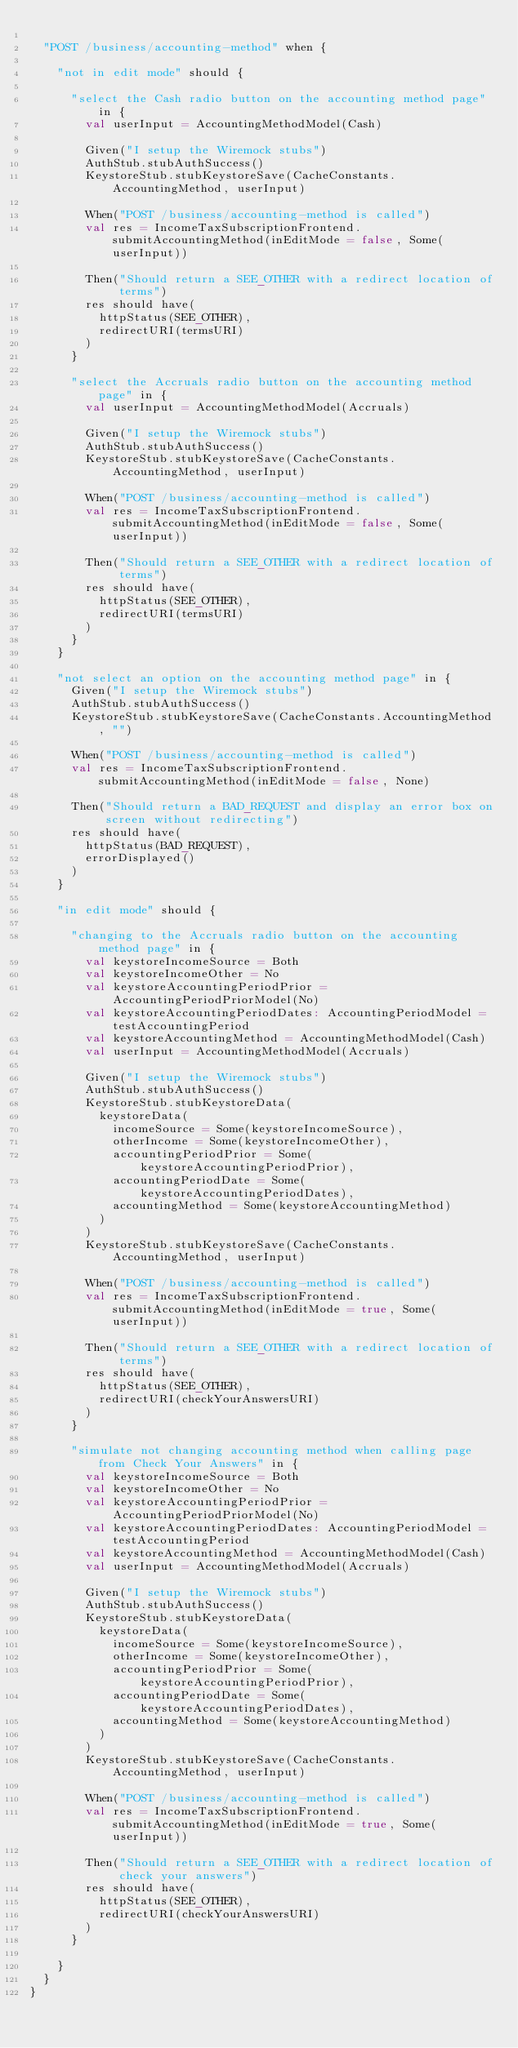Convert code to text. <code><loc_0><loc_0><loc_500><loc_500><_Scala_>
  "POST /business/accounting-method" when {

    "not in edit mode" should {

      "select the Cash radio button on the accounting method page" in {
        val userInput = AccountingMethodModel(Cash)

        Given("I setup the Wiremock stubs")
        AuthStub.stubAuthSuccess()
        KeystoreStub.stubKeystoreSave(CacheConstants.AccountingMethod, userInput)

        When("POST /business/accounting-method is called")
        val res = IncomeTaxSubscriptionFrontend.submitAccountingMethod(inEditMode = false, Some(userInput))

        Then("Should return a SEE_OTHER with a redirect location of terms")
        res should have(
          httpStatus(SEE_OTHER),
          redirectURI(termsURI)
        )
      }

      "select the Accruals radio button on the accounting method page" in {
        val userInput = AccountingMethodModel(Accruals)

        Given("I setup the Wiremock stubs")
        AuthStub.stubAuthSuccess()
        KeystoreStub.stubKeystoreSave(CacheConstants.AccountingMethod, userInput)

        When("POST /business/accounting-method is called")
        val res = IncomeTaxSubscriptionFrontend.submitAccountingMethod(inEditMode = false, Some(userInput))

        Then("Should return a SEE_OTHER with a redirect location of terms")
        res should have(
          httpStatus(SEE_OTHER),
          redirectURI(termsURI)
        )
      }
    }

    "not select an option on the accounting method page" in {
      Given("I setup the Wiremock stubs")
      AuthStub.stubAuthSuccess()
      KeystoreStub.stubKeystoreSave(CacheConstants.AccountingMethod, "")

      When("POST /business/accounting-method is called")
      val res = IncomeTaxSubscriptionFrontend.submitAccountingMethod(inEditMode = false, None)

      Then("Should return a BAD_REQUEST and display an error box on screen without redirecting")
      res should have(
        httpStatus(BAD_REQUEST),
        errorDisplayed()
      )
    }

    "in edit mode" should {

      "changing to the Accruals radio button on the accounting method page" in {
        val keystoreIncomeSource = Both
        val keystoreIncomeOther = No
        val keystoreAccountingPeriodPrior = AccountingPeriodPriorModel(No)
        val keystoreAccountingPeriodDates: AccountingPeriodModel = testAccountingPeriod
        val keystoreAccountingMethod = AccountingMethodModel(Cash)
        val userInput = AccountingMethodModel(Accruals)

        Given("I setup the Wiremock stubs")
        AuthStub.stubAuthSuccess()
        KeystoreStub.stubKeystoreData(
          keystoreData(
            incomeSource = Some(keystoreIncomeSource),
            otherIncome = Some(keystoreIncomeOther),
            accountingPeriodPrior = Some(keystoreAccountingPeriodPrior),
            accountingPeriodDate = Some(keystoreAccountingPeriodDates),
            accountingMethod = Some(keystoreAccountingMethod)
          )
        )
        KeystoreStub.stubKeystoreSave(CacheConstants.AccountingMethod, userInput)

        When("POST /business/accounting-method is called")
        val res = IncomeTaxSubscriptionFrontend.submitAccountingMethod(inEditMode = true, Some(userInput))

        Then("Should return a SEE_OTHER with a redirect location of terms")
        res should have(
          httpStatus(SEE_OTHER),
          redirectURI(checkYourAnswersURI)
        )
      }

      "simulate not changing accounting method when calling page from Check Your Answers" in {
        val keystoreIncomeSource = Both
        val keystoreIncomeOther = No
        val keystoreAccountingPeriodPrior = AccountingPeriodPriorModel(No)
        val keystoreAccountingPeriodDates: AccountingPeriodModel = testAccountingPeriod
        val keystoreAccountingMethod = AccountingMethodModel(Cash)
        val userInput = AccountingMethodModel(Accruals)

        Given("I setup the Wiremock stubs")
        AuthStub.stubAuthSuccess()
        KeystoreStub.stubKeystoreData(
          keystoreData(
            incomeSource = Some(keystoreIncomeSource),
            otherIncome = Some(keystoreIncomeOther),
            accountingPeriodPrior = Some(keystoreAccountingPeriodPrior),
            accountingPeriodDate = Some(keystoreAccountingPeriodDates),
            accountingMethod = Some(keystoreAccountingMethod)
          )
        )
        KeystoreStub.stubKeystoreSave(CacheConstants.AccountingMethod, userInput)

        When("POST /business/accounting-method is called")
        val res = IncomeTaxSubscriptionFrontend.submitAccountingMethod(inEditMode = true, Some(userInput))

        Then("Should return a SEE_OTHER with a redirect location of check your answers")
        res should have(
          httpStatus(SEE_OTHER),
          redirectURI(checkYourAnswersURI)
        )
      }

    }
  }
}
</code> 